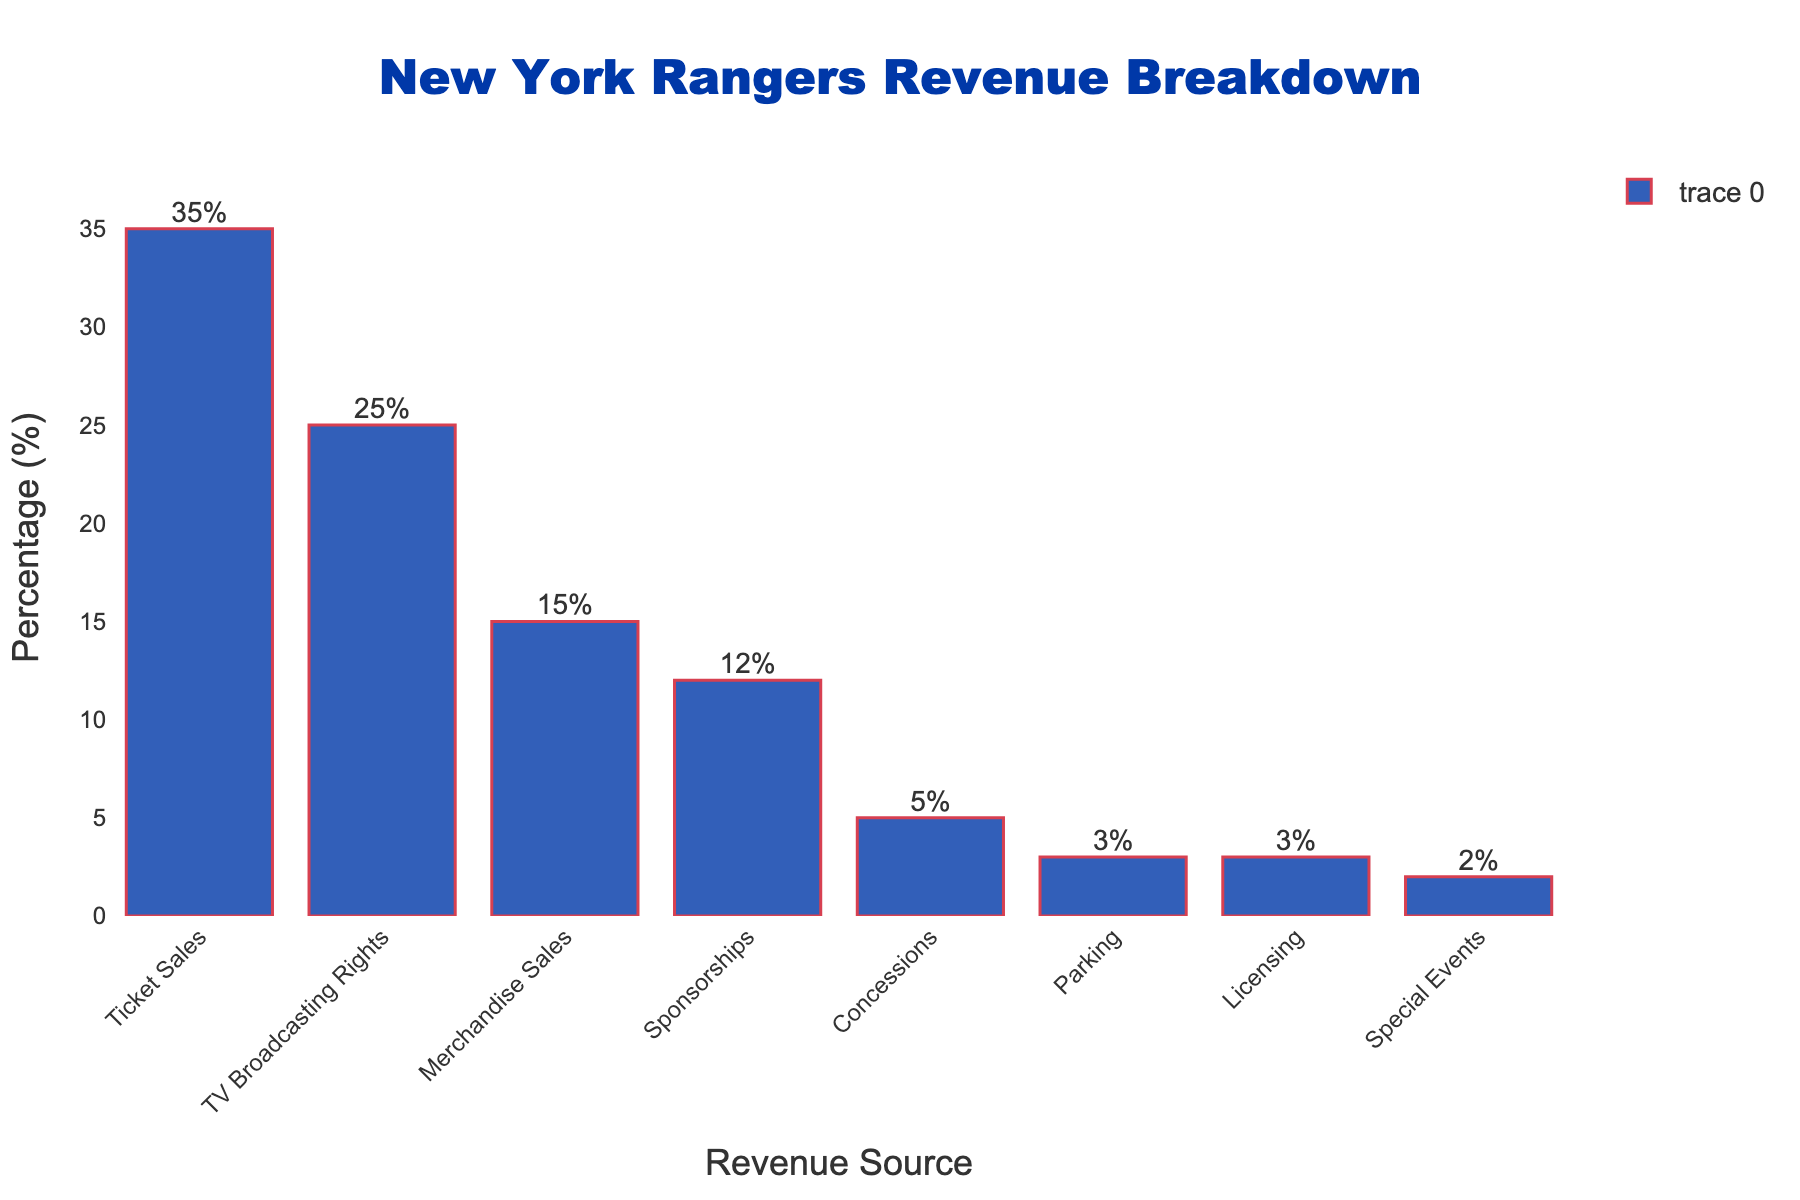What is the largest revenue source for the New York Rangers? The figure shows that the category with the highest revenue percentage is Ticket Sales, which is represented by the tallest bar.
Answer: Ticket Sales What is the combined percentage of revenue from Sponsorships and Concessions? To find the combined percentage, add the percentage from Sponsorships (12%) to the percentage from Concessions (5%). 12% + 5% = 17%
Answer: 17% Which category contributes more to the revenue: Parking or Licensing? By comparing the heights of the bars and the labels, both Parking and Licensing have the same percentage of 3%.
Answer: Equal How much larger is the revenue percentage from TV Broadcasting Rights compared to Merchandise Sales? Subtract the revenue percentage from Merchandise Sales (15%) from the percentage from TV Broadcasting Rights (25%). 25% - 15% = 10%
Answer: 10% What is the sum of the revenue percentages from Ticket Sales, TV Broadcasting Rights, and Merchandise Sales? Add the revenue percentages from Ticket Sales (35%), TV Broadcasting Rights (25%), and Merchandise Sales (15%). 35% + 25% + 15% = 75%
Answer: 75% Which revenue source has the smallest contribution to the New York Rangers' revenue? The shortest bar in the figure and its label indicate that Special Events have the smallest contribution at 2%.
Answer: Special Events How do the contributions from Concessions and Parking compare to each other? The bar for Concessions is taller than the bar for Parking, and the labels show 5% for Concessions and 3% for Parking.
Answer: Concessions > Parking What is the average revenue percentage of Licensing, Parking, and Special Events? To find the average, add the percentages for Licensing (3%), Parking (3%), and Special Events (2%), then divide by 3. (3% + 3% + 2%) / 3 = 8% / 3 ≈ 2.67%
Answer: 2.67% Is the revenue from Merchandise Sales more than double the revenue from Sponsorships? Compare twice the revenue percentage from Sponsorships (12% * 2 = 24%) to the revenue percentage from Merchandise Sales (15%). 15% is not more than 24%.
Answer: No 